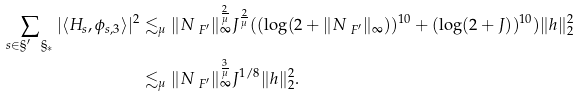Convert formula to latex. <formula><loc_0><loc_0><loc_500><loc_500>\sum _ { s \in \S ^ { \prime } \ \S _ { * } } | \langle H _ { s } , \phi _ { s , 3 } \rangle | ^ { 2 } & \lesssim _ { \mu } \| N _ { \ F ^ { \prime } } \| _ { \infty } ^ { \frac { 2 } { \mu } } J ^ { \frac { 2 } { \mu } } ( ( \log ( 2 + \| N _ { \ F ^ { \prime } } \| _ { \infty } ) ) ^ { 1 0 } + ( \log ( 2 + J ) ) ^ { 1 0 } ) \| h \| _ { 2 } ^ { 2 } \\ & \lesssim _ { \mu } \| N _ { \ F ^ { \prime } } \| _ { \infty } ^ { \frac { 3 } { \mu } } J ^ { 1 / 8 } \| h \| _ { 2 } ^ { 2 } .</formula> 